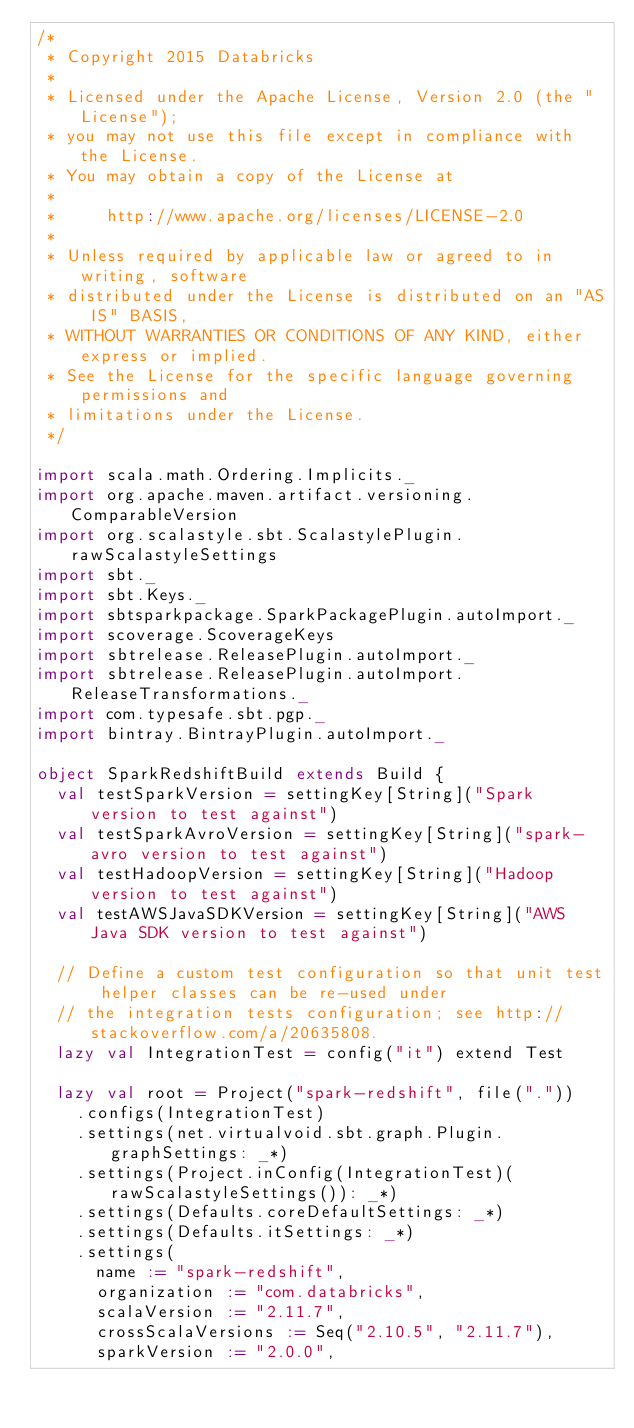Convert code to text. <code><loc_0><loc_0><loc_500><loc_500><_Scala_>/*
 * Copyright 2015 Databricks
 *
 * Licensed under the Apache License, Version 2.0 (the "License");
 * you may not use this file except in compliance with the License.
 * You may obtain a copy of the License at
 *
 *     http://www.apache.org/licenses/LICENSE-2.0
 *
 * Unless required by applicable law or agreed to in writing, software
 * distributed under the License is distributed on an "AS IS" BASIS,
 * WITHOUT WARRANTIES OR CONDITIONS OF ANY KIND, either express or implied.
 * See the License for the specific language governing permissions and
 * limitations under the License.
 */

import scala.math.Ordering.Implicits._
import org.apache.maven.artifact.versioning.ComparableVersion
import org.scalastyle.sbt.ScalastylePlugin.rawScalastyleSettings
import sbt._
import sbt.Keys._
import sbtsparkpackage.SparkPackagePlugin.autoImport._
import scoverage.ScoverageKeys
import sbtrelease.ReleasePlugin.autoImport._
import sbtrelease.ReleasePlugin.autoImport.ReleaseTransformations._
import com.typesafe.sbt.pgp._
import bintray.BintrayPlugin.autoImport._

object SparkRedshiftBuild extends Build {
  val testSparkVersion = settingKey[String]("Spark version to test against")
  val testSparkAvroVersion = settingKey[String]("spark-avro version to test against")
  val testHadoopVersion = settingKey[String]("Hadoop version to test against")
  val testAWSJavaSDKVersion = settingKey[String]("AWS Java SDK version to test against")

  // Define a custom test configuration so that unit test helper classes can be re-used under
  // the integration tests configuration; see http://stackoverflow.com/a/20635808.
  lazy val IntegrationTest = config("it") extend Test

  lazy val root = Project("spark-redshift", file("."))
    .configs(IntegrationTest)
    .settings(net.virtualvoid.sbt.graph.Plugin.graphSettings: _*)
    .settings(Project.inConfig(IntegrationTest)(rawScalastyleSettings()): _*)
    .settings(Defaults.coreDefaultSettings: _*)
    .settings(Defaults.itSettings: _*)
    .settings(
      name := "spark-redshift",
      organization := "com.databricks",
      scalaVersion := "2.11.7",
      crossScalaVersions := Seq("2.10.5", "2.11.7"),
      sparkVersion := "2.0.0",</code> 